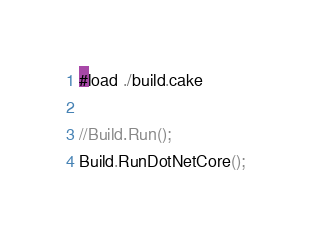<code> <loc_0><loc_0><loc_500><loc_500><_C#_>#load ./build.cake

//Build.Run();
Build.RunDotNetCore();</code> 